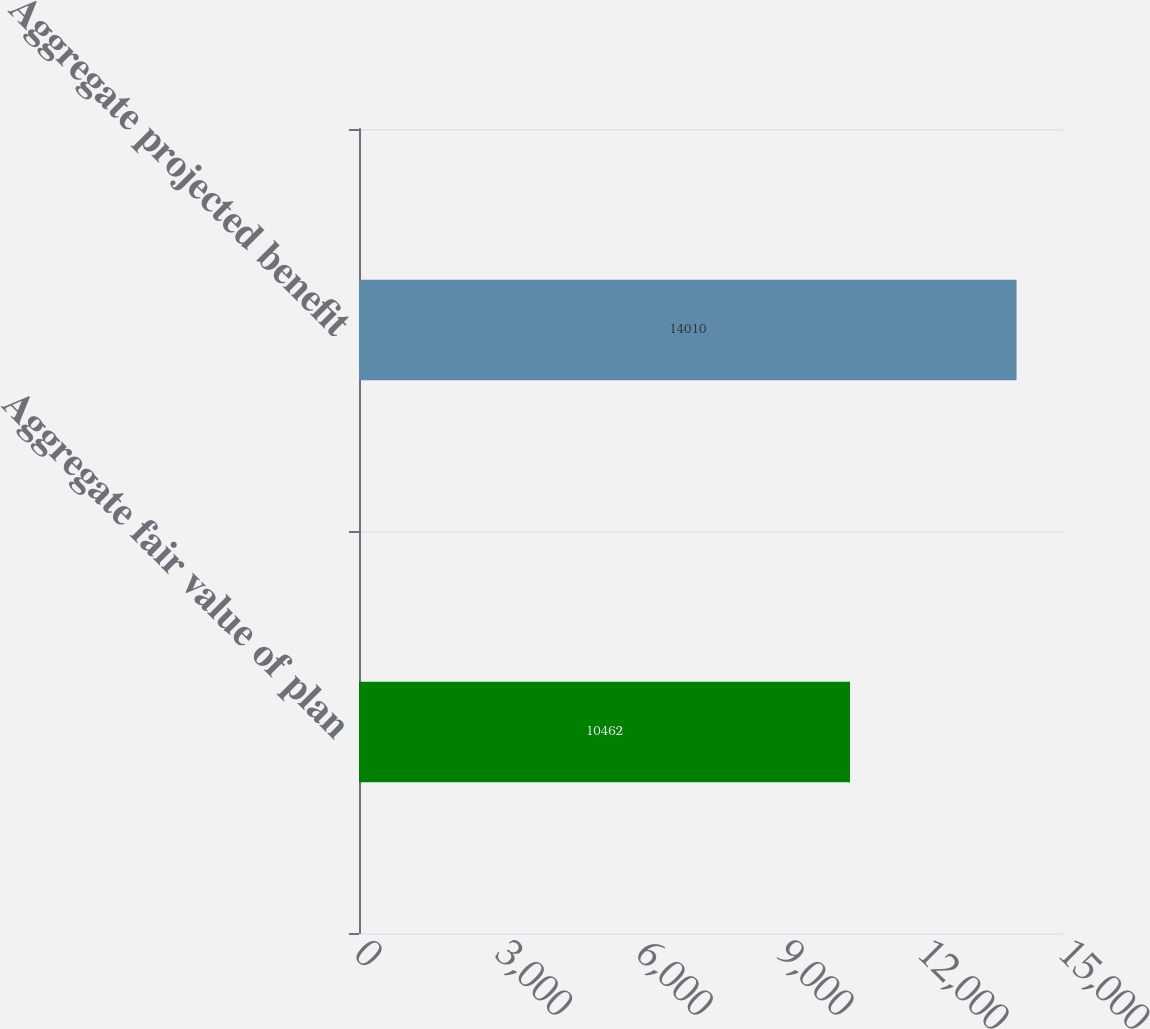Convert chart to OTSL. <chart><loc_0><loc_0><loc_500><loc_500><bar_chart><fcel>Aggregate fair value of plan<fcel>Aggregate projected benefit<nl><fcel>10462<fcel>14010<nl></chart> 